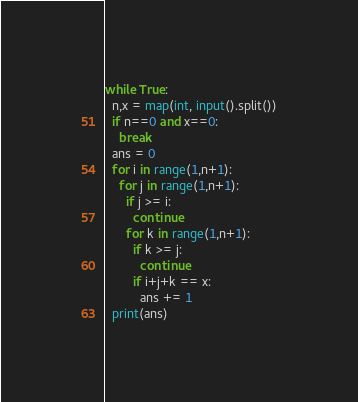Convert code to text. <code><loc_0><loc_0><loc_500><loc_500><_Python_>while True:
  n,x = map(int, input().split())
  if n==0 and x==0:
    break
  ans = 0
  for i in range(1,n+1):
    for j in range(1,n+1):
      if j >= i:
        continue
      for k in range(1,n+1):
        if k >= j:
          continue
        if i+j+k == x:
          ans += 1
  print(ans)
</code> 